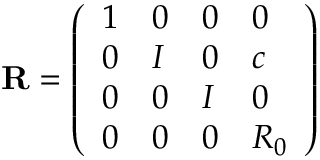<formula> <loc_0><loc_0><loc_500><loc_500>{ R } = \left ( \begin{array} { l l l l } { 1 } & { 0 } & { 0 } & { 0 } \\ { 0 } & { I } & { 0 } & { c } \\ { 0 } & { 0 } & { I } & { 0 } \\ { 0 } & { 0 } & { 0 } & { { R _ { 0 } } } \end{array} \right )</formula> 